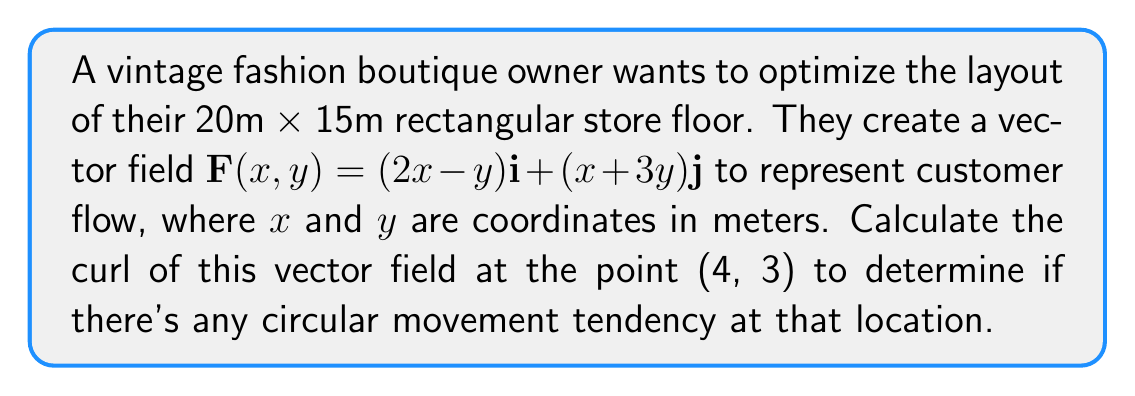Give your solution to this math problem. To solve this problem, we need to calculate the curl of the given vector field at the specified point. The curl of a vector field in two dimensions is given by:

$$\text{curl }\mathbf{F} = \nabla \times \mathbf{F} = \frac{\partial F_y}{\partial x} - \frac{\partial F_x}{\partial y}$$

Where $F_x$ and $F_y$ are the x and y components of the vector field, respectively.

Step 1: Identify the components of the vector field.
$F_x = 2x-y$
$F_y = x+3y$

Step 2: Calculate the partial derivatives.
$\frac{\partial F_y}{\partial x} = 1$
$\frac{\partial F_x}{\partial y} = -1$

Step 3: Apply the curl formula.
$$\text{curl }\mathbf{F} = \frac{\partial F_y}{\partial x} - \frac{\partial F_x}{\partial y} = 1 - (-1) = 2$$

Step 4: The curl is constant throughout the vector field, so it's the same at all points, including (4, 3).

The positive curl value indicates a counterclockwise rotational tendency in the customer flow at the point (4, 3) and throughout the store.
Answer: 2 